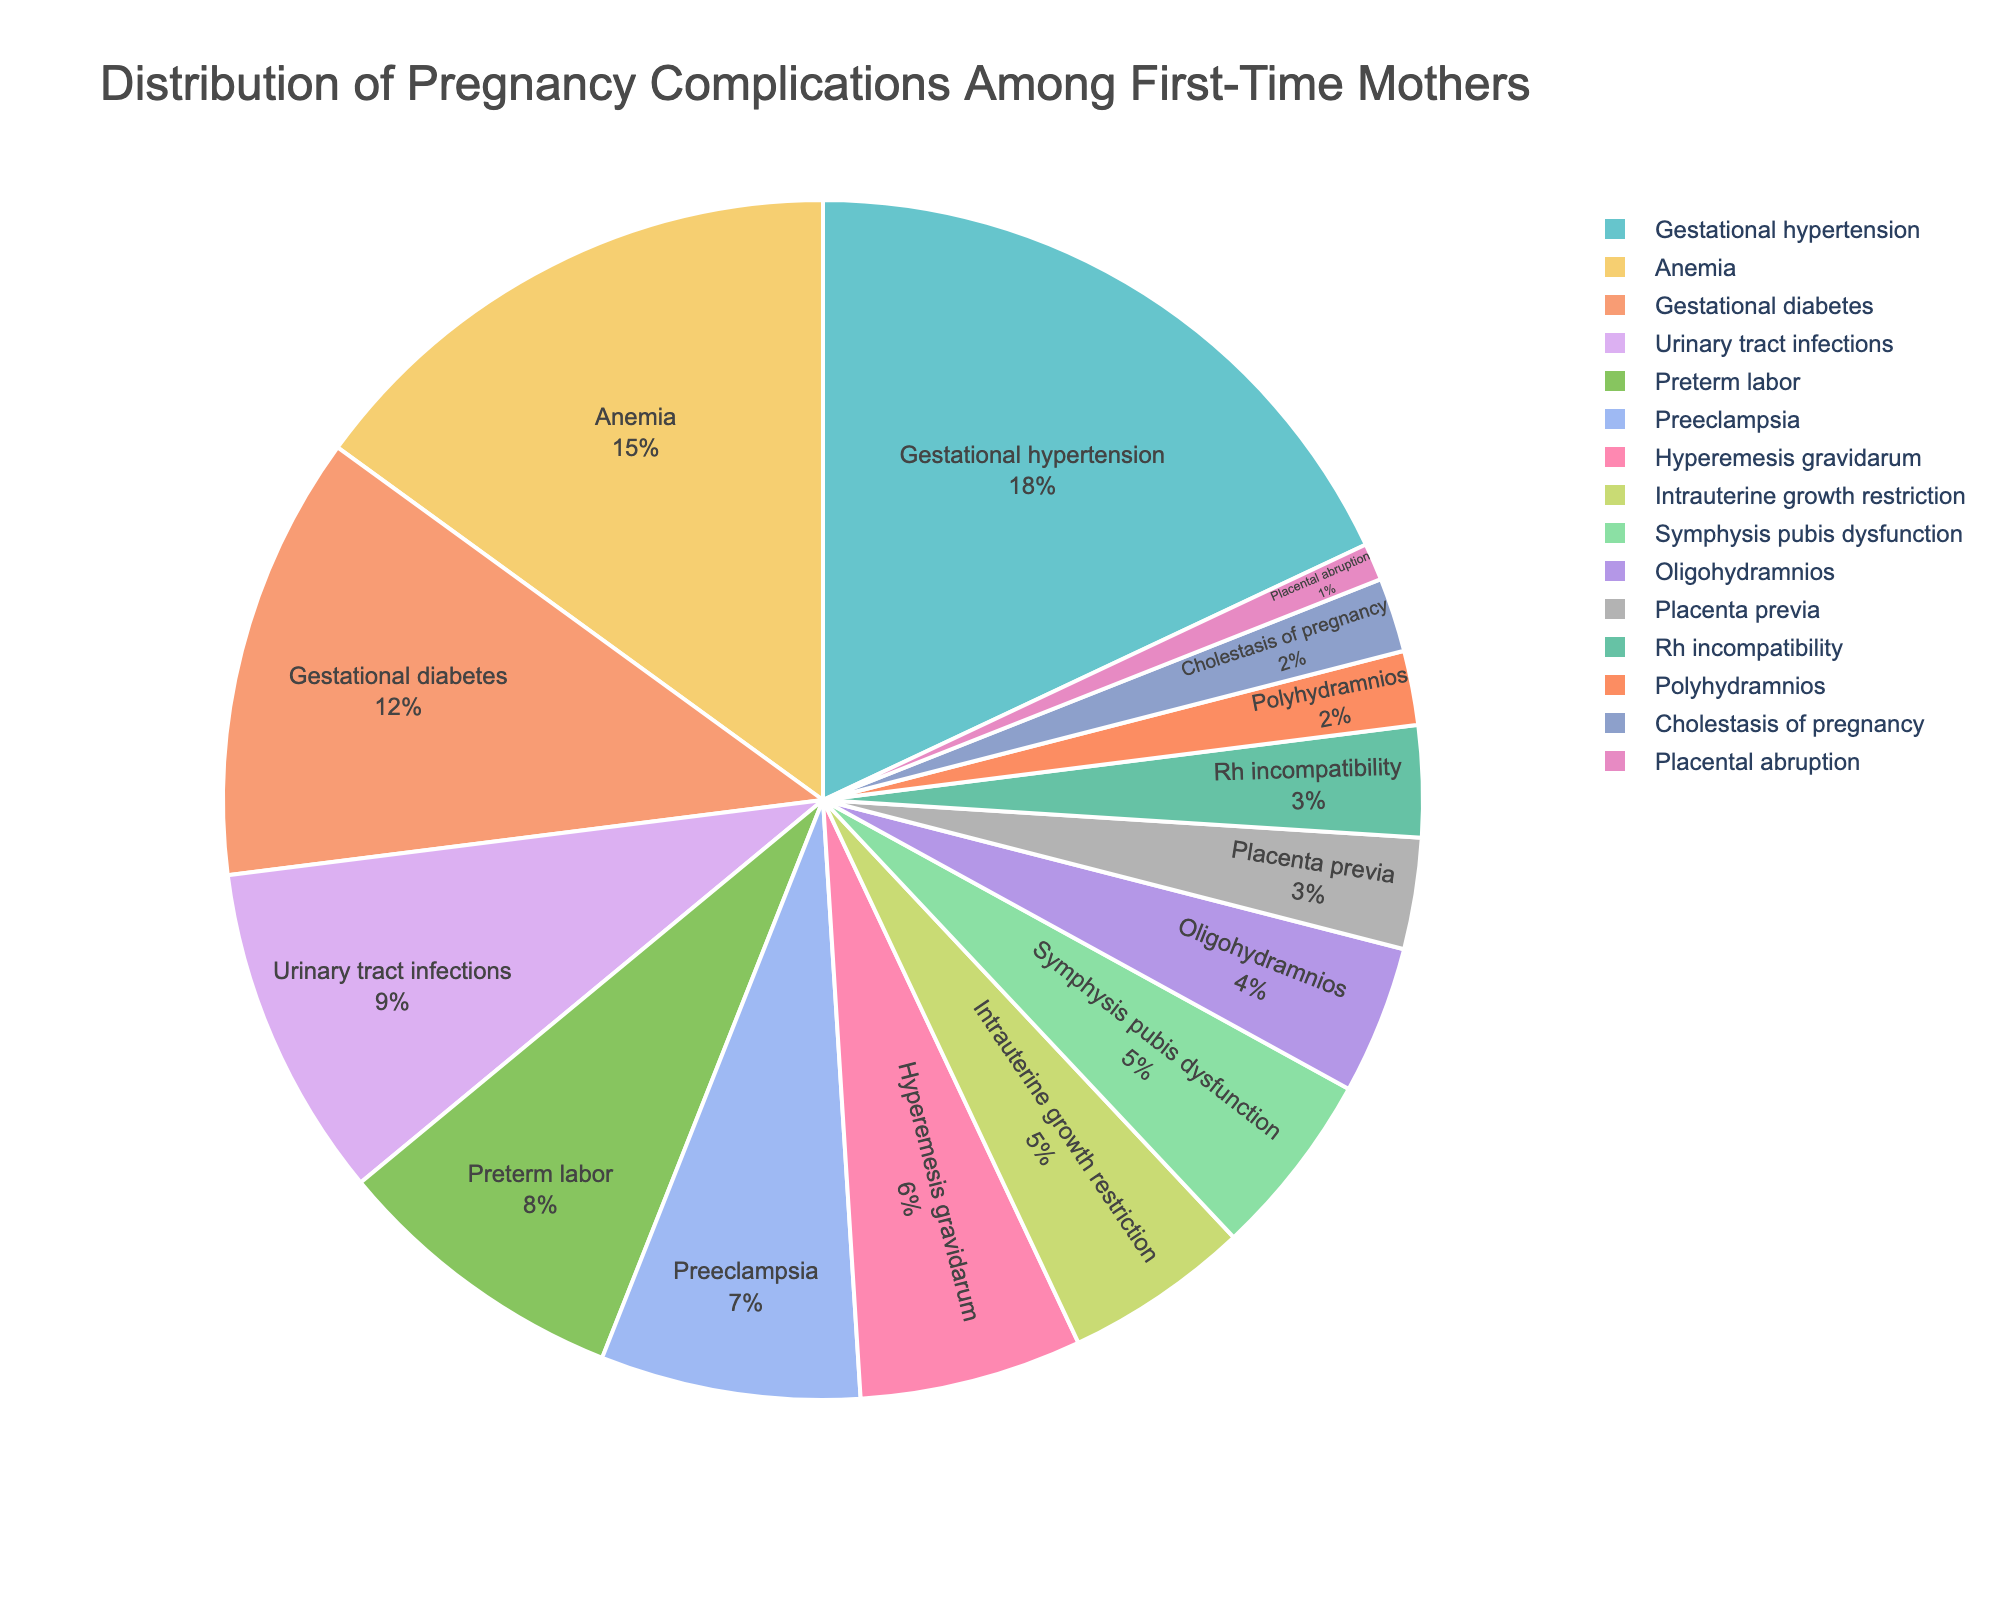Which complication accounts for the highest percentage among first-time mothers? Find the largest percentage value in the pie chart; in this case, Gestational hypertension has the highest percentage of 18%.
Answer: Gestational hypertension What is the combined percentage of Preeclampsia and Gestational Diabetes? Add the percentages of Preeclampsia (7%) and Gestational Diabetes (12%): 7 + 12 = 19%.
Answer: 19% Is the percentage of Anemia greater than that of Urinary tract infections? Compare the percentages of Anemia (15%) and Urinary tract infections (9%) to see that 15 is greater than 9.
Answer: Yes What is the difference in percentage between Hyperemesis gravidarum and Oligohydramnios? Subtract the percentage of Oligohydramnios (4%) from Hyperemesis gravidarum (6%): 6 - 4 = 2%.
Answer: 2% Which complication has the smallest percentage, and what is it? Identify the smallest percentage value in the pie chart, which is Placental abruption at 1%.
Answer: Placental abruption, 1% How does the percentage of Preterm labor compare to that of Intrauterine growth restriction? Check the percentages for Preterm labor (8%) and Intrauterine growth restriction (5%) to see that 8 is greater than 5.
Answer: Preterm labor is higher What is the total percentage for complications under 5%? Sum the percentages for complications under 5%: Placenta previa (3%), Intrauterine growth restriction (5%), Oligohydramnios (4%), Polyhydramnios (2%), Cholestasis of pregnancy (2%), Symphysis pubis dysfunction (5%), Placental abruption (1%), Rh incompatibility (3%): 3 + 5 + 4 + 2 + 2 + 5 + 1 + 3 = 25%.
Answer: 25% Which complication occupies the fifth-largest segment in the pie chart? List the complications by descending order of percentage: Gestational hypertension (18%), Anemia (15%), Gestational Diabetes (12%), Urinary tract infections (9%), Preterm labor (8%). The fifth is Preterm labor.
Answer: Preterm labor What portions of the pie are covered by complications related to the placenta (Placenta previa and Placental abruption)? Add the percentages of Placenta previa (3%) and Placental abruption (1%): 3 + 1 = 4%.
Answer: 4% Is the percentage of Cholestasis of pregnancy equal to that of Polyhydramnios? Compare the percentages of Cholestasis of pregnancy (2%) and Polyhydramnios (2%) to confirm they are equal.
Answer: Yes 